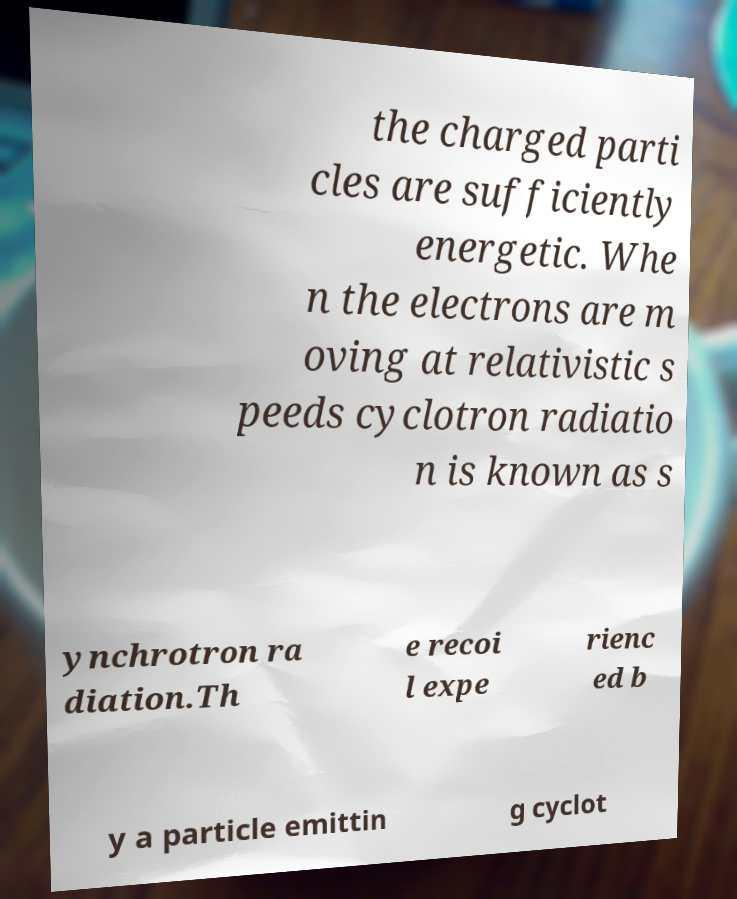Can you accurately transcribe the text from the provided image for me? the charged parti cles are sufficiently energetic. Whe n the electrons are m oving at relativistic s peeds cyclotron radiatio n is known as s ynchrotron ra diation.Th e recoi l expe rienc ed b y a particle emittin g cyclot 